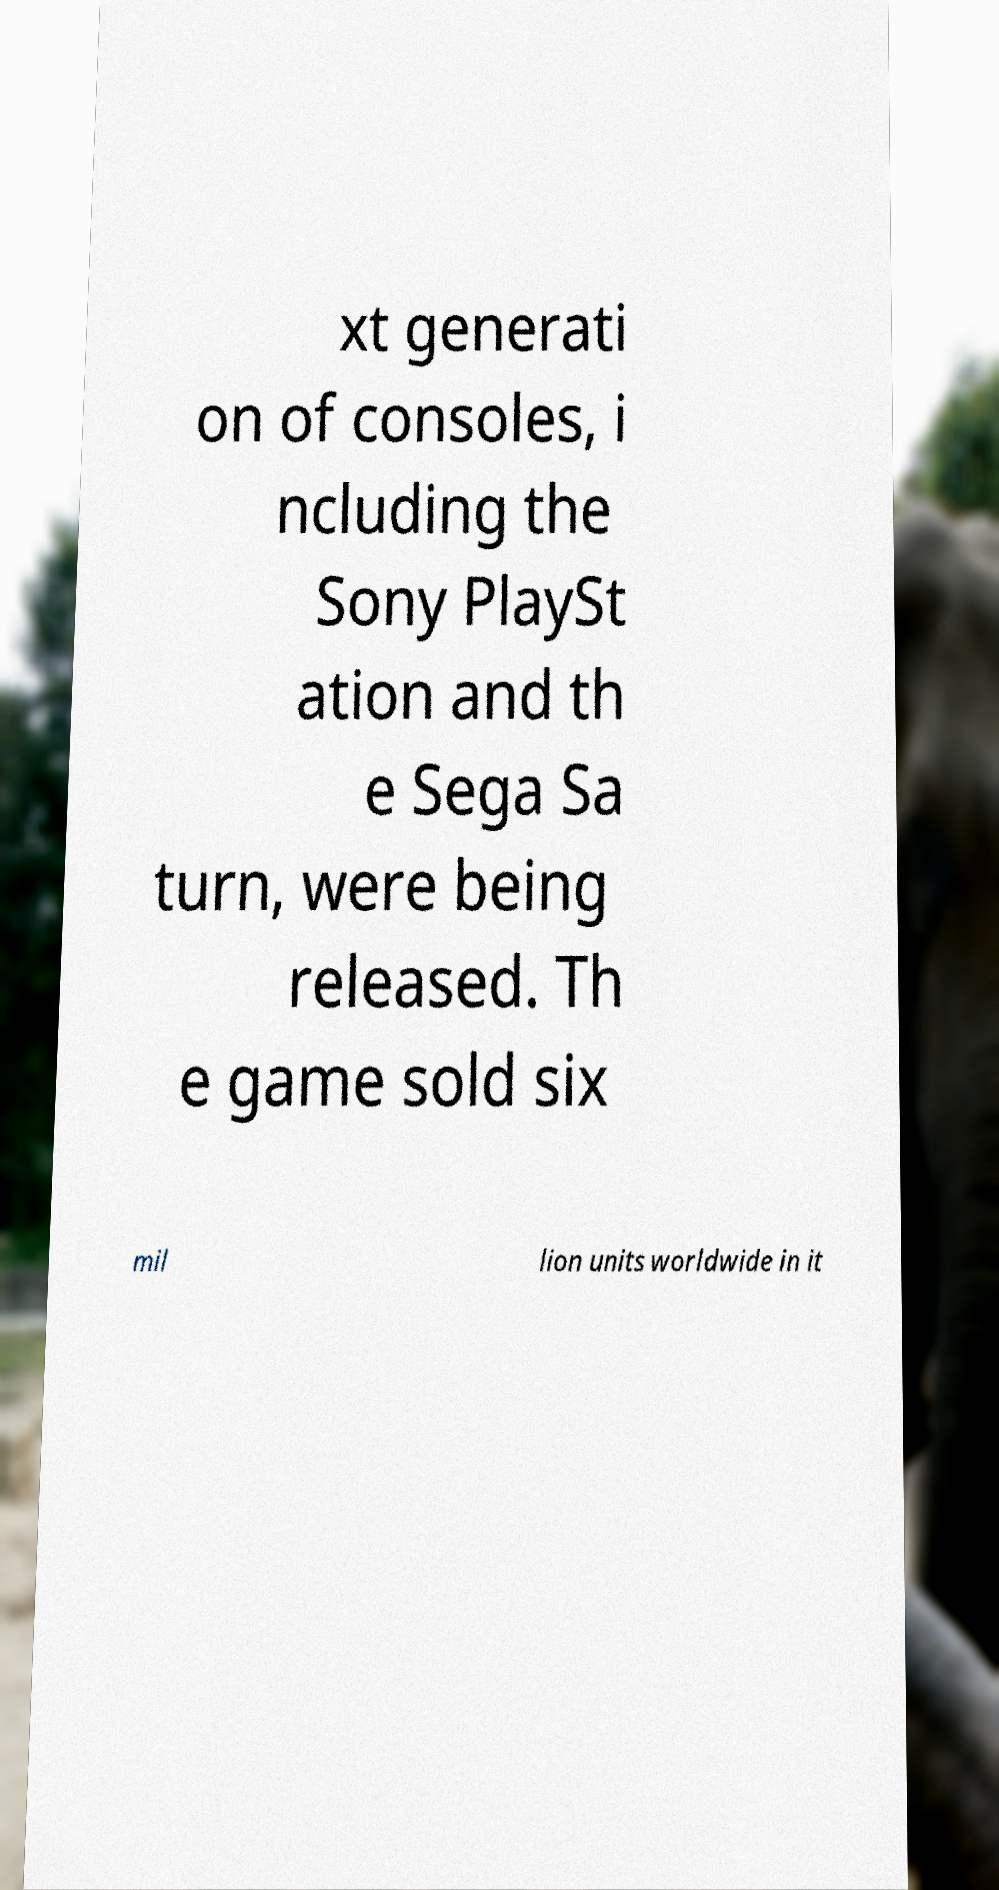Could you extract and type out the text from this image? xt generati on of consoles, i ncluding the Sony PlaySt ation and th e Sega Sa turn, were being released. Th e game sold six mil lion units worldwide in it 